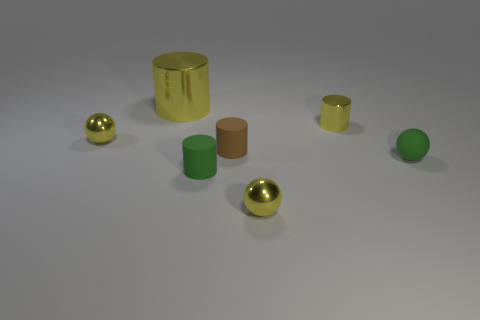There is a shiny cylinder to the right of the small yellow ball in front of the tiny brown matte object; what is its size?
Ensure brevity in your answer.  Small. What material is the yellow cylinder that is the same size as the green rubber sphere?
Ensure brevity in your answer.  Metal. There is a large shiny cylinder; are there any small yellow balls behind it?
Offer a terse response. No. Are there an equal number of large yellow things in front of the brown matte object and purple rubber cubes?
Offer a very short reply. Yes. What is the shape of the brown matte object that is the same size as the green matte cylinder?
Your answer should be compact. Cylinder. What is the big cylinder made of?
Offer a very short reply. Metal. There is a small shiny thing that is both behind the small green ball and left of the tiny metal cylinder; what is its color?
Your answer should be compact. Yellow. Are there the same number of green things that are on the right side of the brown object and small green objects in front of the rubber sphere?
Make the answer very short. Yes. The cylinder that is the same material as the brown object is what color?
Ensure brevity in your answer.  Green. There is a large metallic thing; is its color the same as the sphere that is on the left side of the big yellow metallic cylinder?
Give a very brief answer. Yes. 